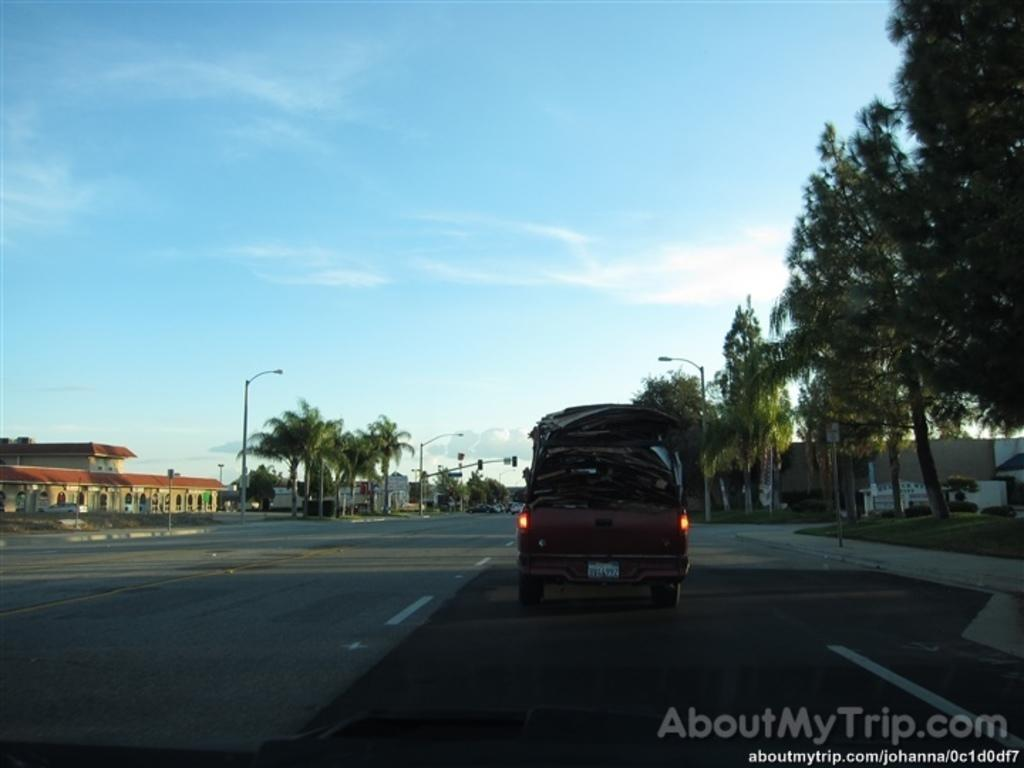What is parked on the road in the image? There is a vehicle parked on the road in the image. What can be seen behind the parked vehicle? There are trees visible behind the vehicle. What is visible in the distance behind the trees? There are buildings in the background. What type of jeans is the vehicle wearing in the image? Vehicles do not wear jeans; they are inanimate objects. 